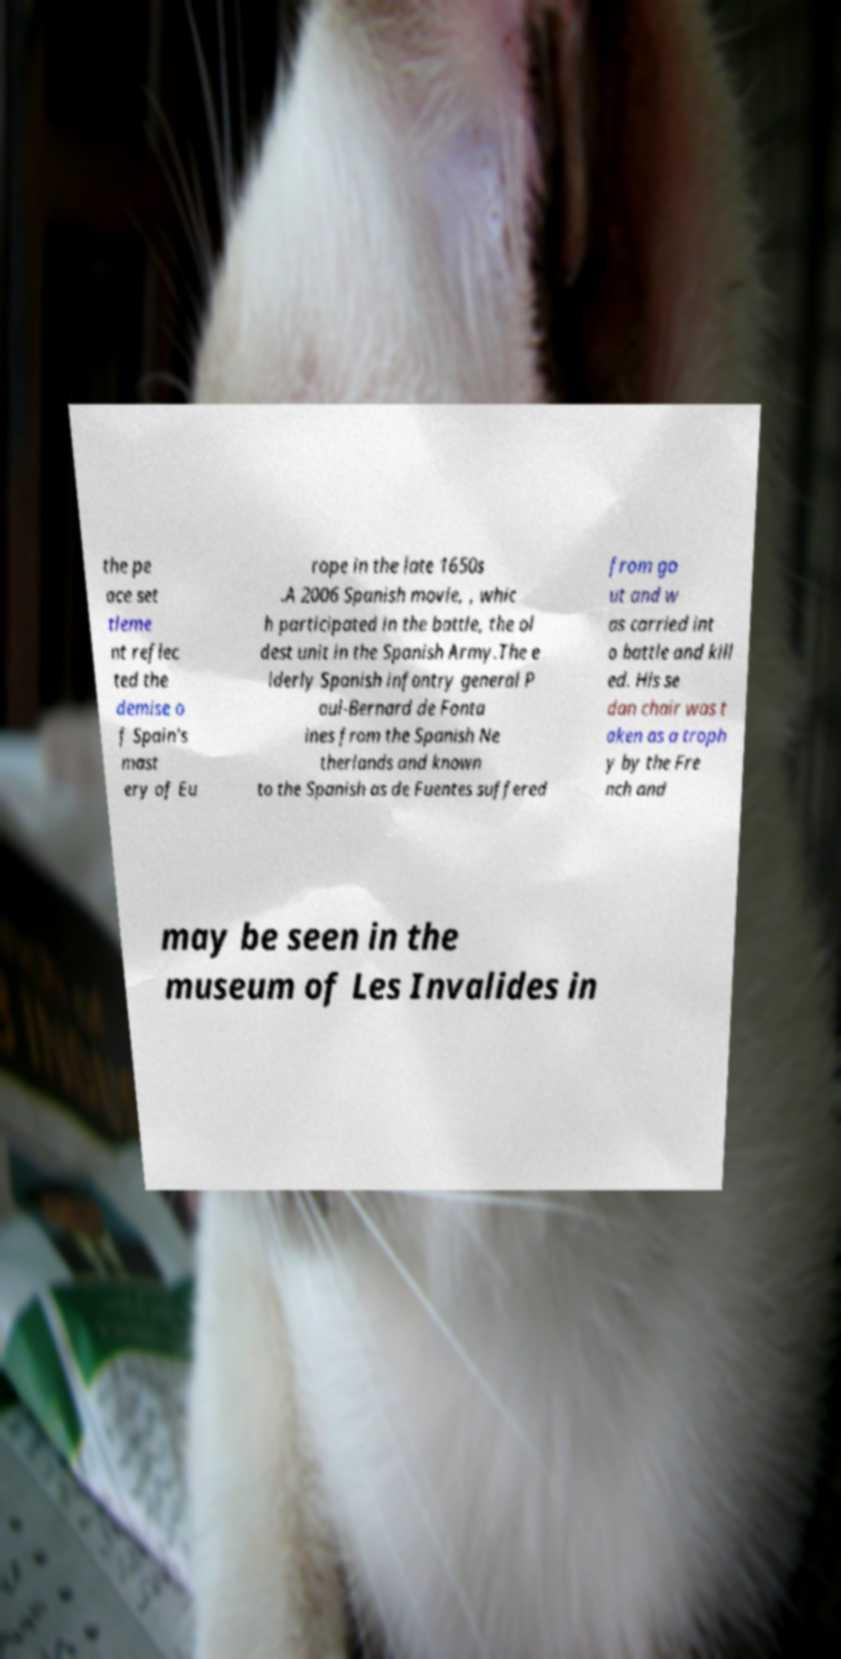Please identify and transcribe the text found in this image. the pe ace set tleme nt reflec ted the demise o f Spain's mast ery of Eu rope in the late 1650s .A 2006 Spanish movie, , whic h participated in the battle, the ol dest unit in the Spanish Army.The e lderly Spanish infantry general P aul-Bernard de Fonta ines from the Spanish Ne therlands and known to the Spanish as de Fuentes suffered from go ut and w as carried int o battle and kill ed. His se dan chair was t aken as a troph y by the Fre nch and may be seen in the museum of Les Invalides in 